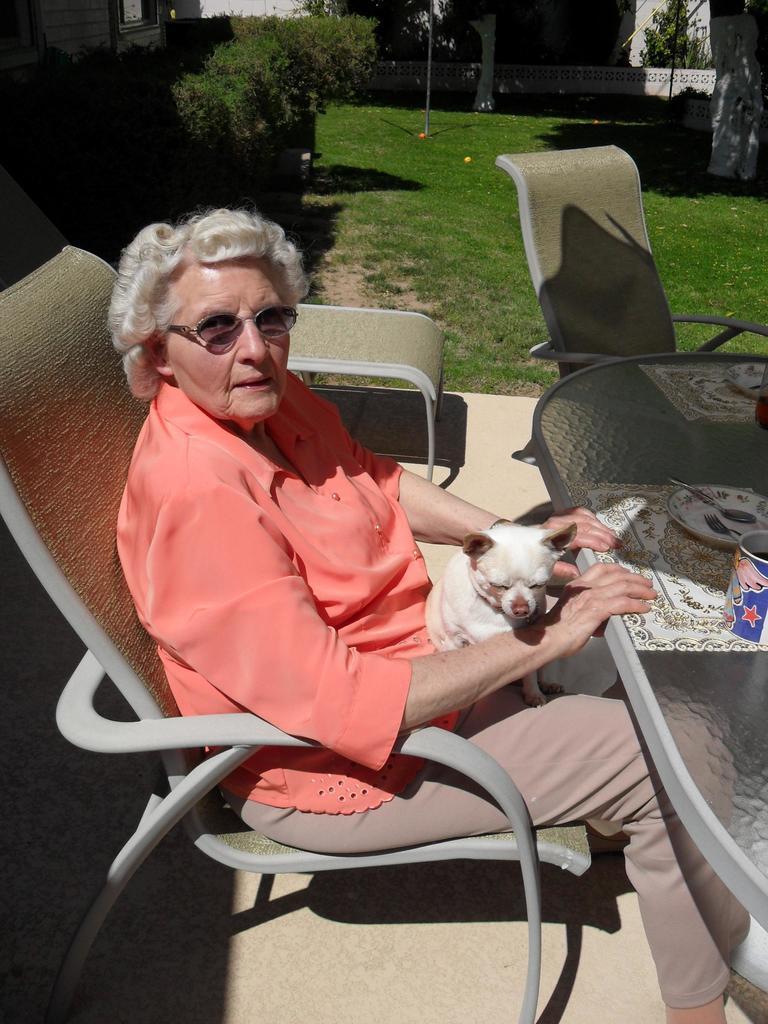Could you give a brief overview of what you see in this image? Here we can see a woman who is sitting on the chair. This is dog and there is a table. On the table there is a plate and this is jar. Here we can see some plants. And this is grass. 